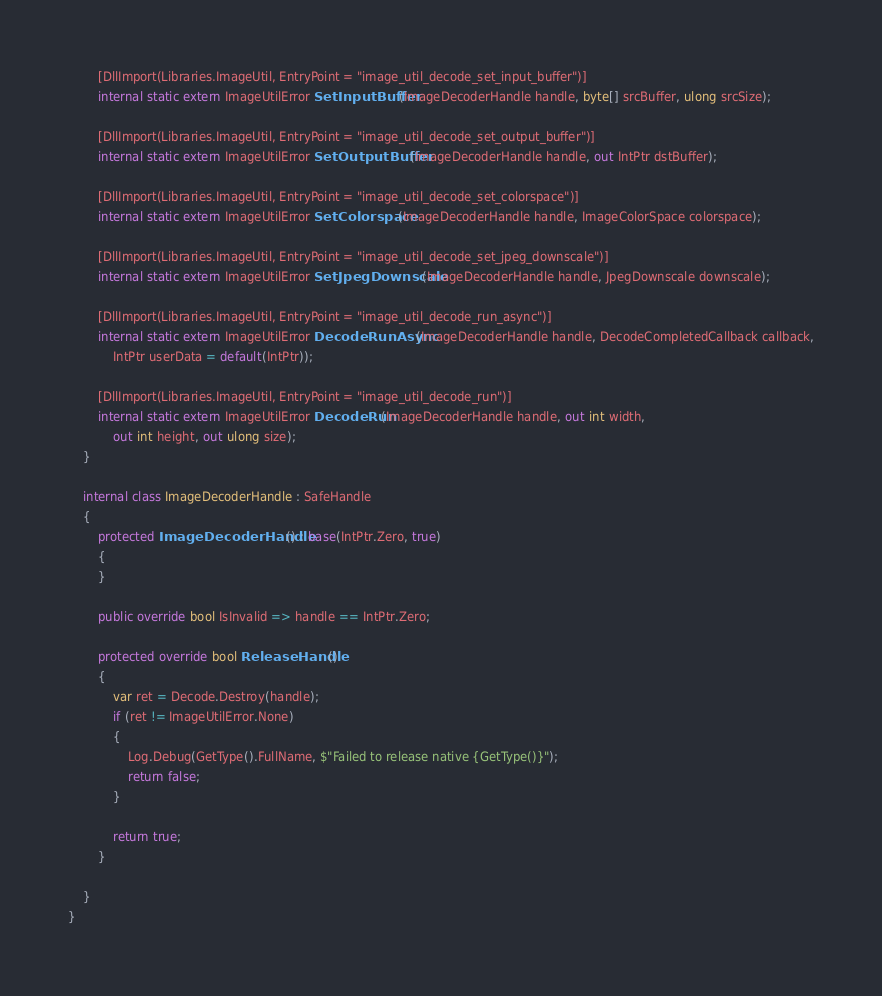<code> <loc_0><loc_0><loc_500><loc_500><_C#_>        [DllImport(Libraries.ImageUtil, EntryPoint = "image_util_decode_set_input_buffer")]
        internal static extern ImageUtilError SetInputBuffer(ImageDecoderHandle handle, byte[] srcBuffer, ulong srcSize);

        [DllImport(Libraries.ImageUtil, EntryPoint = "image_util_decode_set_output_buffer")]
        internal static extern ImageUtilError SetOutputBuffer(ImageDecoderHandle handle, out IntPtr dstBuffer);

        [DllImport(Libraries.ImageUtil, EntryPoint = "image_util_decode_set_colorspace")]
        internal static extern ImageUtilError SetColorspace(ImageDecoderHandle handle, ImageColorSpace colorspace);

        [DllImport(Libraries.ImageUtil, EntryPoint = "image_util_decode_set_jpeg_downscale")]
        internal static extern ImageUtilError SetJpegDownscale(ImageDecoderHandle handle, JpegDownscale downscale);

        [DllImport(Libraries.ImageUtil, EntryPoint = "image_util_decode_run_async")]
        internal static extern ImageUtilError DecodeRunAsync(ImageDecoderHandle handle, DecodeCompletedCallback callback,
            IntPtr userData = default(IntPtr));

        [DllImport(Libraries.ImageUtil, EntryPoint = "image_util_decode_run")]
        internal static extern ImageUtilError DecodeRun(ImageDecoderHandle handle, out int width,
            out int height, out ulong size);
    }

    internal class ImageDecoderHandle : SafeHandle
    {
        protected ImageDecoderHandle() : base(IntPtr.Zero, true)
        {
        }

        public override bool IsInvalid => handle == IntPtr.Zero;

        protected override bool ReleaseHandle()
        {
            var ret = Decode.Destroy(handle);
            if (ret != ImageUtilError.None)
            {
                Log.Debug(GetType().FullName, $"Failed to release native {GetType()}");
                return false;
            }

            return true;
        }

    }
}
</code> 